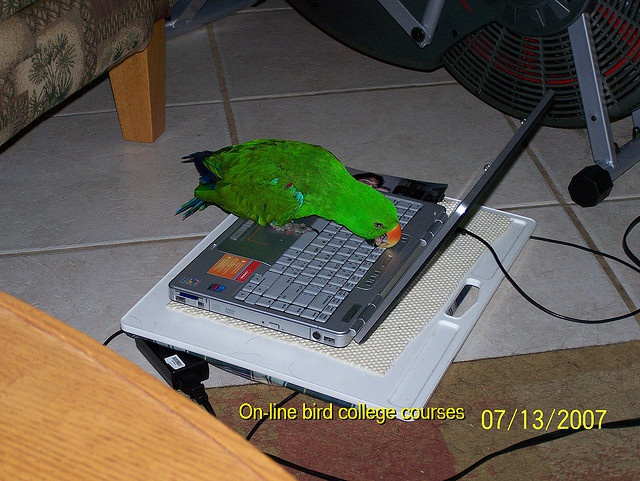Describe the objects in this image and their specific colors. I can see bench in black, tan, and gray tones, laptop in black and gray tones, keyboard in black, gray, and darkgray tones, chair in black, maroon, and gray tones, and bird in black, darkgreen, green, and gray tones in this image. 